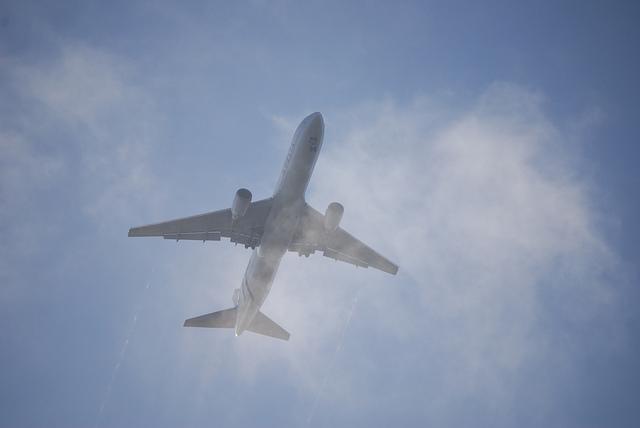Are there clouds visible?
Short answer required. Yes. Was this picture taken at 2 pm?
Write a very short answer. Yes. Is the plane on fire?
Quick response, please. No. Is the plane surrounded by clouds?
Short answer required. Yes. Is this a passenger jet?
Give a very brief answer. Yes. 